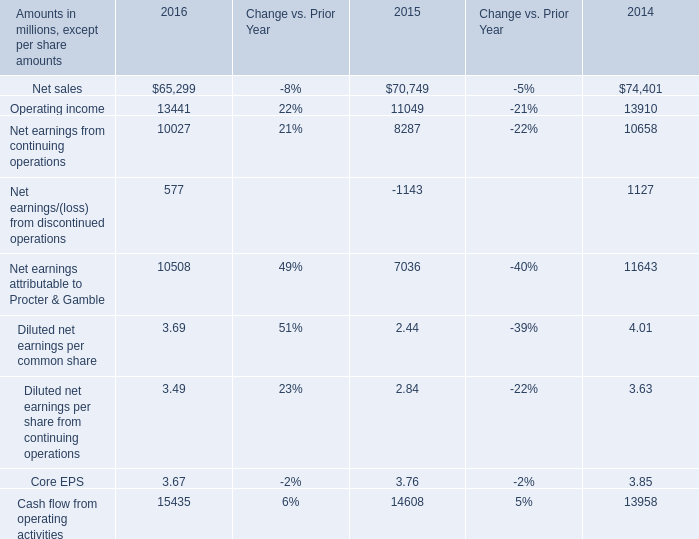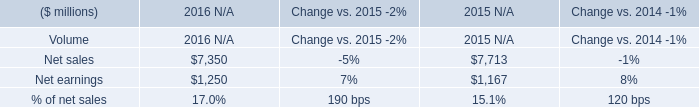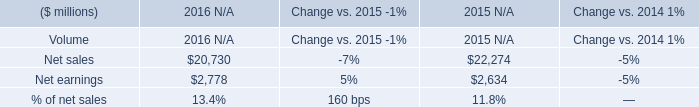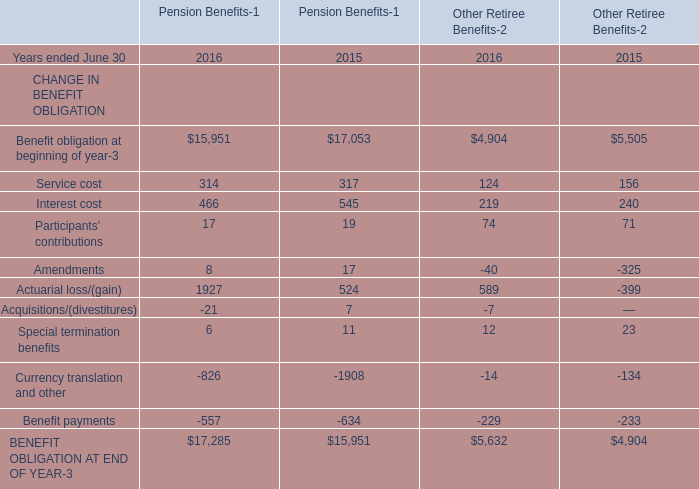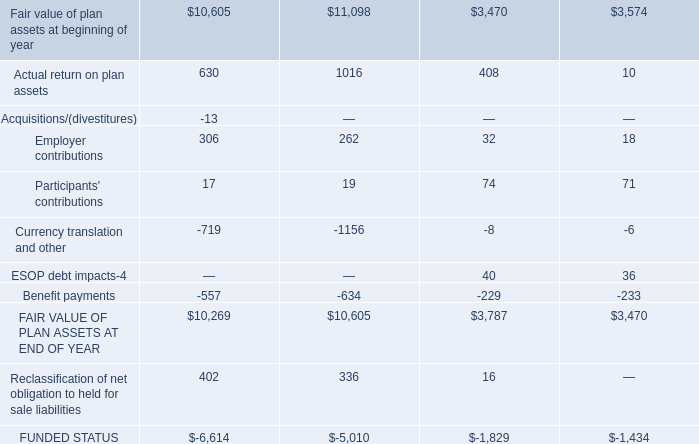What's the sum of Currency translation and other, and BENEFIT OBLIGATION AT END OF YEAR of Pension Benefits 2016 ? 
Computations: (1156.0 + 17285.0)
Answer: 18441.0. 